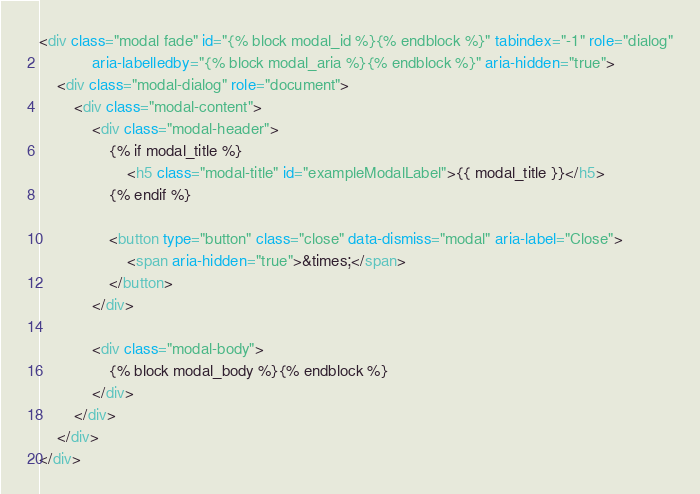<code> <loc_0><loc_0><loc_500><loc_500><_HTML_><div class="modal fade" id="{% block modal_id %}{% endblock %}" tabindex="-1" role="dialog"
            aria-labelledby="{% block modal_aria %}{% endblock %}" aria-hidden="true">
    <div class="modal-dialog" role="document">
        <div class="modal-content">
            <div class="modal-header">
                {% if modal_title %}
                    <h5 class="modal-title" id="exampleModalLabel">{{ modal_title }}</h5>
                {% endif %}

                <button type="button" class="close" data-dismiss="modal" aria-label="Close">
                    <span aria-hidden="true">&times;</span>
                </button>
            </div>

            <div class="modal-body">
                {% block modal_body %}{% endblock %}
            </div>
        </div>
    </div>
</div>
</code> 